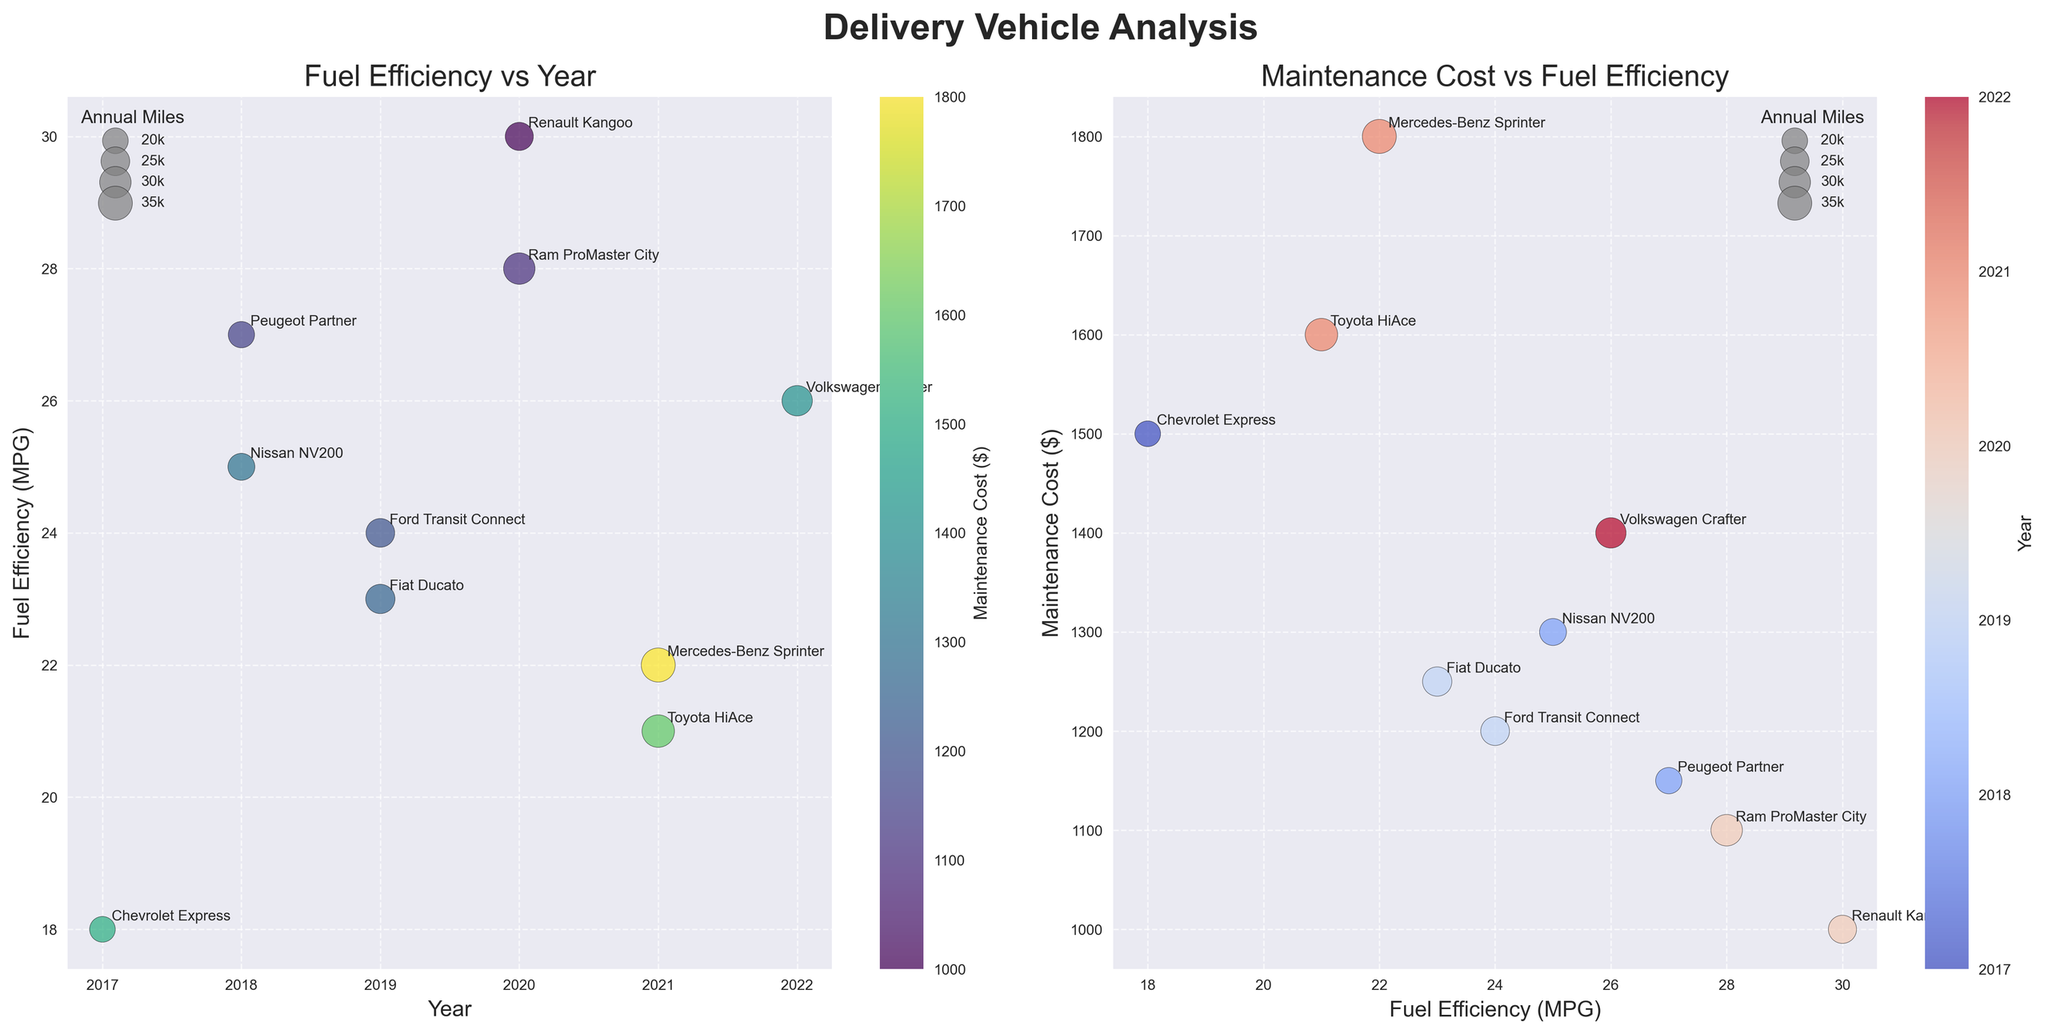What is the title of the first bubble chart? The title of the first bubble chart is found at the top of the left subplot. It reads "Fuel Efficiency vs Year".
Answer: Fuel Efficiency vs Year Which vehicle has the best fuel efficiency? The vehicle with the best fuel efficiency has the highest value on the y-axis in both bubble charts. In this case, it is the Renault Kangoo with 30 MPG.
Answer: Renault Kangoo What is the maintenance cost for the Mercedes-Benz Sprinter? The maintenance cost for the Mercedes-Benz Sprinter is represented by the color in both bubble charts. By looking at the color legend and the points, the cost is $1800.
Answer: $1800 In which year did the vehicle with the worst fuel efficiency come out? The vehicle with the worst fuel efficiency is the one with the lowest value on the y-axis in both bubble charts. The Chevrolet Express with 18 MPG came out in 2017.
Answer: 2017 Among all vehicles, which one travels the most annual miles? The vehicle that travels the most annual miles is represented by the largest bubble in both charts. The Mercedes-Benz Sprinter has the largest bubble, indicating it travels 35,000 miles annually.
Answer: Mercedes-Benz Sprinter Which vehicle model has the highest maintenance cost for a given fuel efficiency? In the right bubble chart, the highest maintenance cost is on the y-axis, and the one with the top bubble in correlation to fuel efficiency is the Mercedes-Benz Sprinter with $1800.
Answer: Mercedes-Benz Sprinter What's the trend of fuel efficiency over the years based on the first bubble chart? Observing the scatter points in the first chart, there is no consistent upward or downward pattern in fuel efficiency over the years as the points are quite scattered.
Answer: No consistent trend Which vehicle model from 2018 offers better fuel efficiency, and what are their costs? Comparing the fuel efficiencies for the 2018 vehicles shown in both bubble charts, the Nissan NV200 has 25 MPG and the Peugeot Partner has 27 MPG. The maintenance costs are $1300 for the Nissan NV200 and $1150 for the Peugeot Partner.
Answer: Peugeot Partner has better efficiency, costs are $1300 and $1150 Which is the oldest vehicle with a fuel efficiency above 25 MPG? By checking the vehicles with fuel efficiency above 25 MPG from the first chart, the oldest model is the Peugeot Partner from 2018.
Answer: Peugeot Partner How do maintenance costs vary by fuel efficiency based on the second bubble chart? The second bubble chart shows a wide range of maintenance costs across different fuel efficiencies, indicating no clear direct relationship.
Answer: No clear direct relationship 